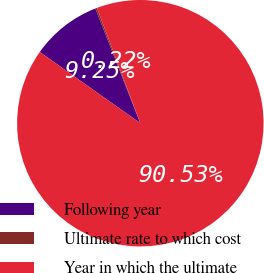Convert chart to OTSL. <chart><loc_0><loc_0><loc_500><loc_500><pie_chart><fcel>Following year<fcel>Ultimate rate to which cost<fcel>Year in which the ultimate<nl><fcel>9.25%<fcel>0.22%<fcel>90.52%<nl></chart> 